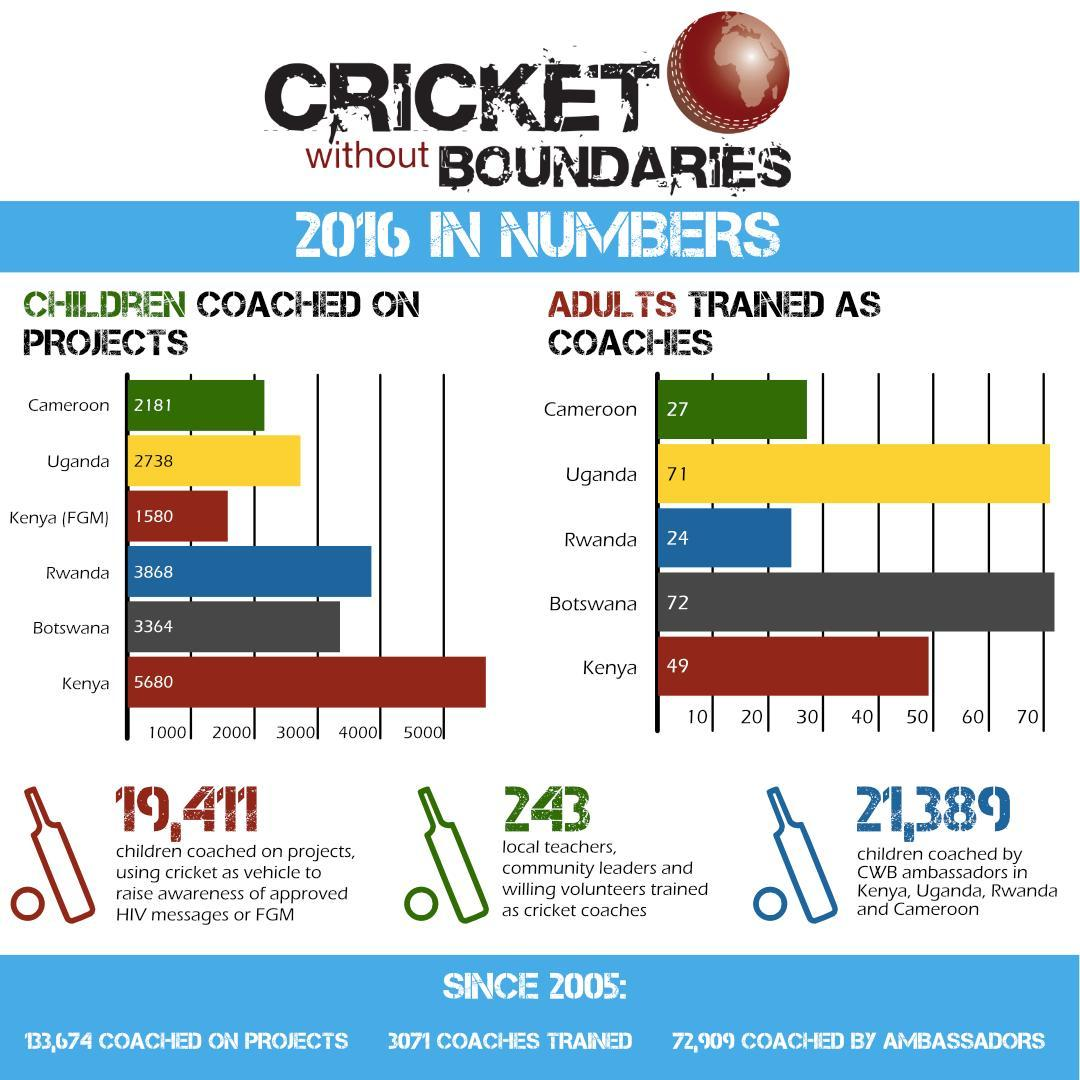How many adults trained as coaches in Uganda and Rwanda, taken together?
Answer the question with a short phrase. 95 How many children coached on projects in Rwanda and Kenya, taken together? 9548 How many adults trained as coaches in Rwanda and Kenya, taken together? 73 How many local teachers, community leaders, and willing volunteers trained as cricket coaches? 243 How many children coached on projects in Cameroon and Uganda, taken together? 4919 